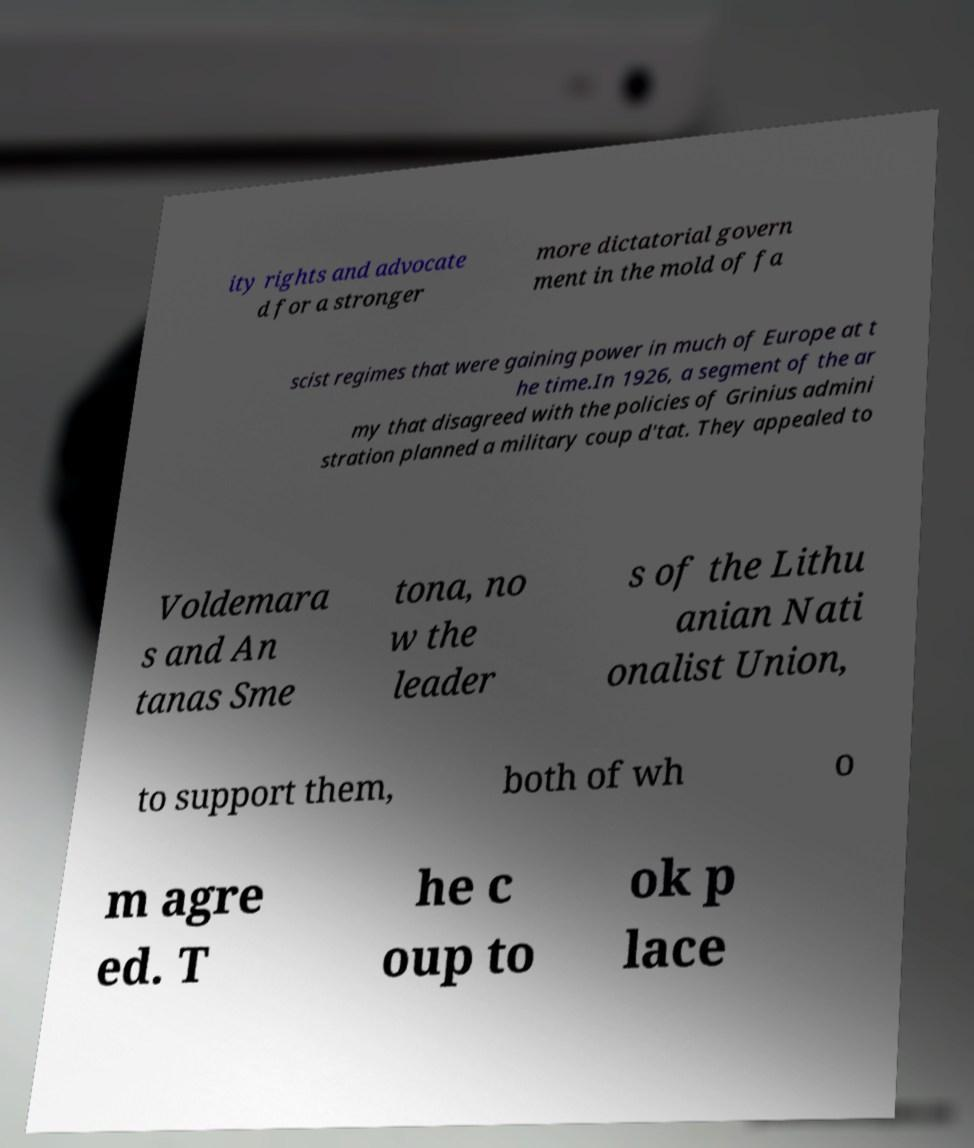What messages or text are displayed in this image? I need them in a readable, typed format. ity rights and advocate d for a stronger more dictatorial govern ment in the mold of fa scist regimes that were gaining power in much of Europe at t he time.In 1926, a segment of the ar my that disagreed with the policies of Grinius admini stration planned a military coup d'tat. They appealed to Voldemara s and An tanas Sme tona, no w the leader s of the Lithu anian Nati onalist Union, to support them, both of wh o m agre ed. T he c oup to ok p lace 